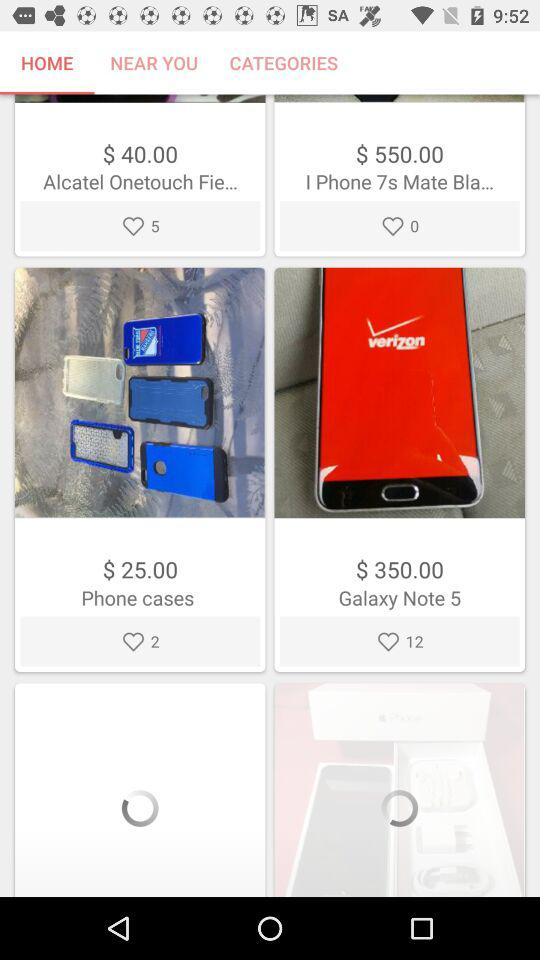What is the price of "Phone cases"? The price is $25. 